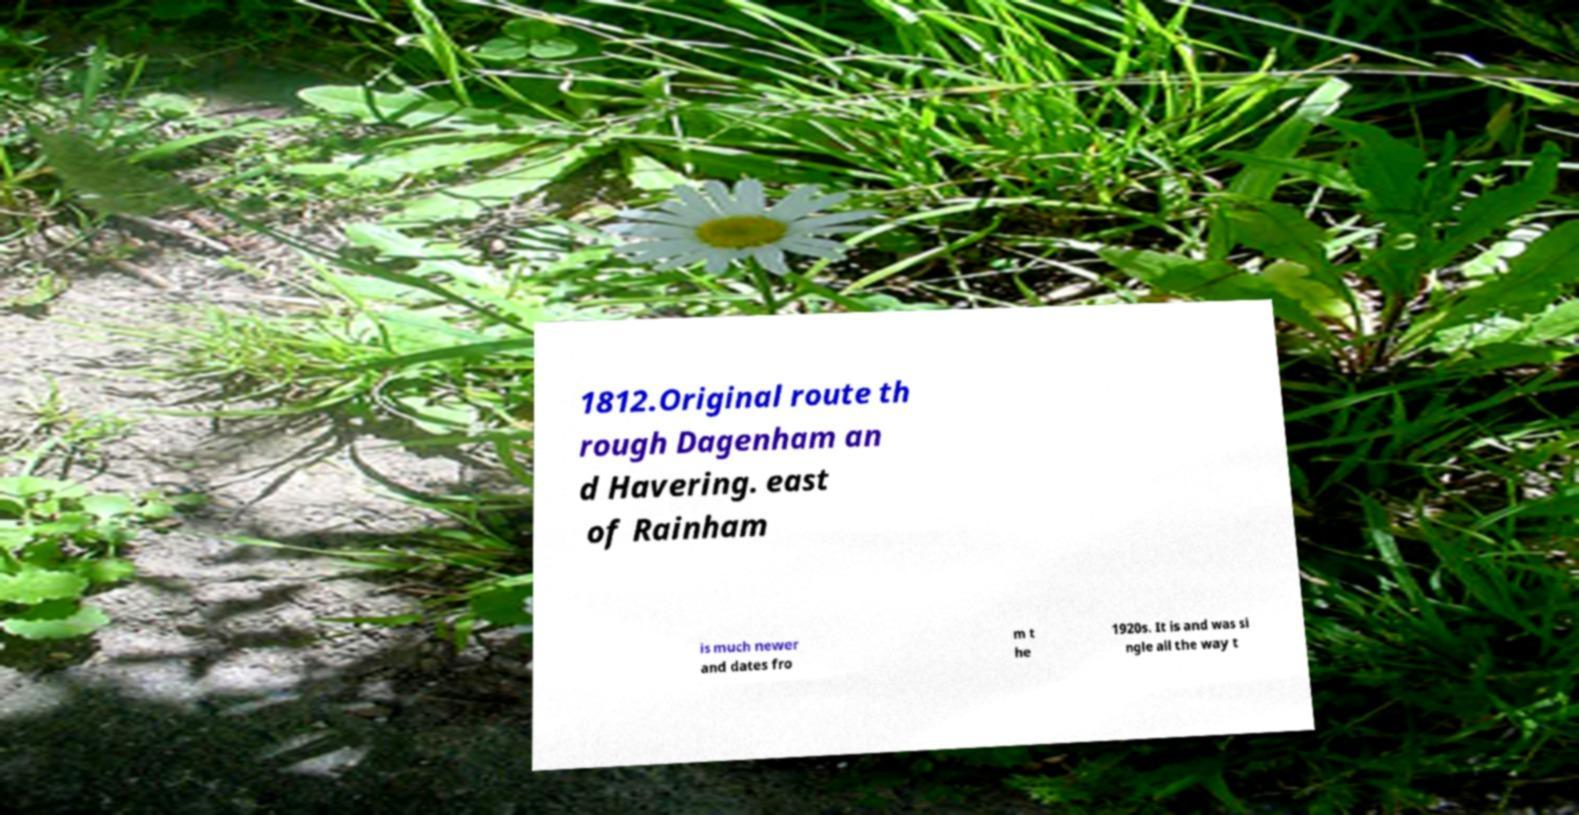There's text embedded in this image that I need extracted. Can you transcribe it verbatim? 1812.Original route th rough Dagenham an d Havering. east of Rainham is much newer and dates fro m t he 1920s. It is and was si ngle all the way t 